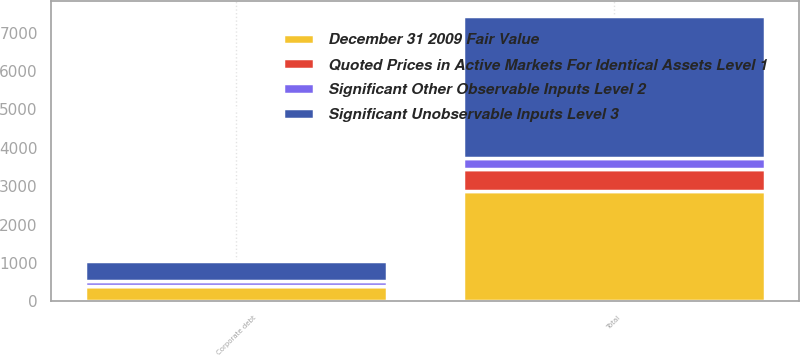<chart> <loc_0><loc_0><loc_500><loc_500><stacked_bar_chart><ecel><fcel>Corporate debt<fcel>Total<nl><fcel>Significant Unobservable Inputs Level 3<fcel>522<fcel>3721<nl><fcel>Quoted Prices in Active Markets For Identical Assets Level 1<fcel>1<fcel>578<nl><fcel>December 31 2009 Fair Value<fcel>404<fcel>2863<nl><fcel>Significant Other Observable Inputs Level 2<fcel>117<fcel>280<nl></chart> 